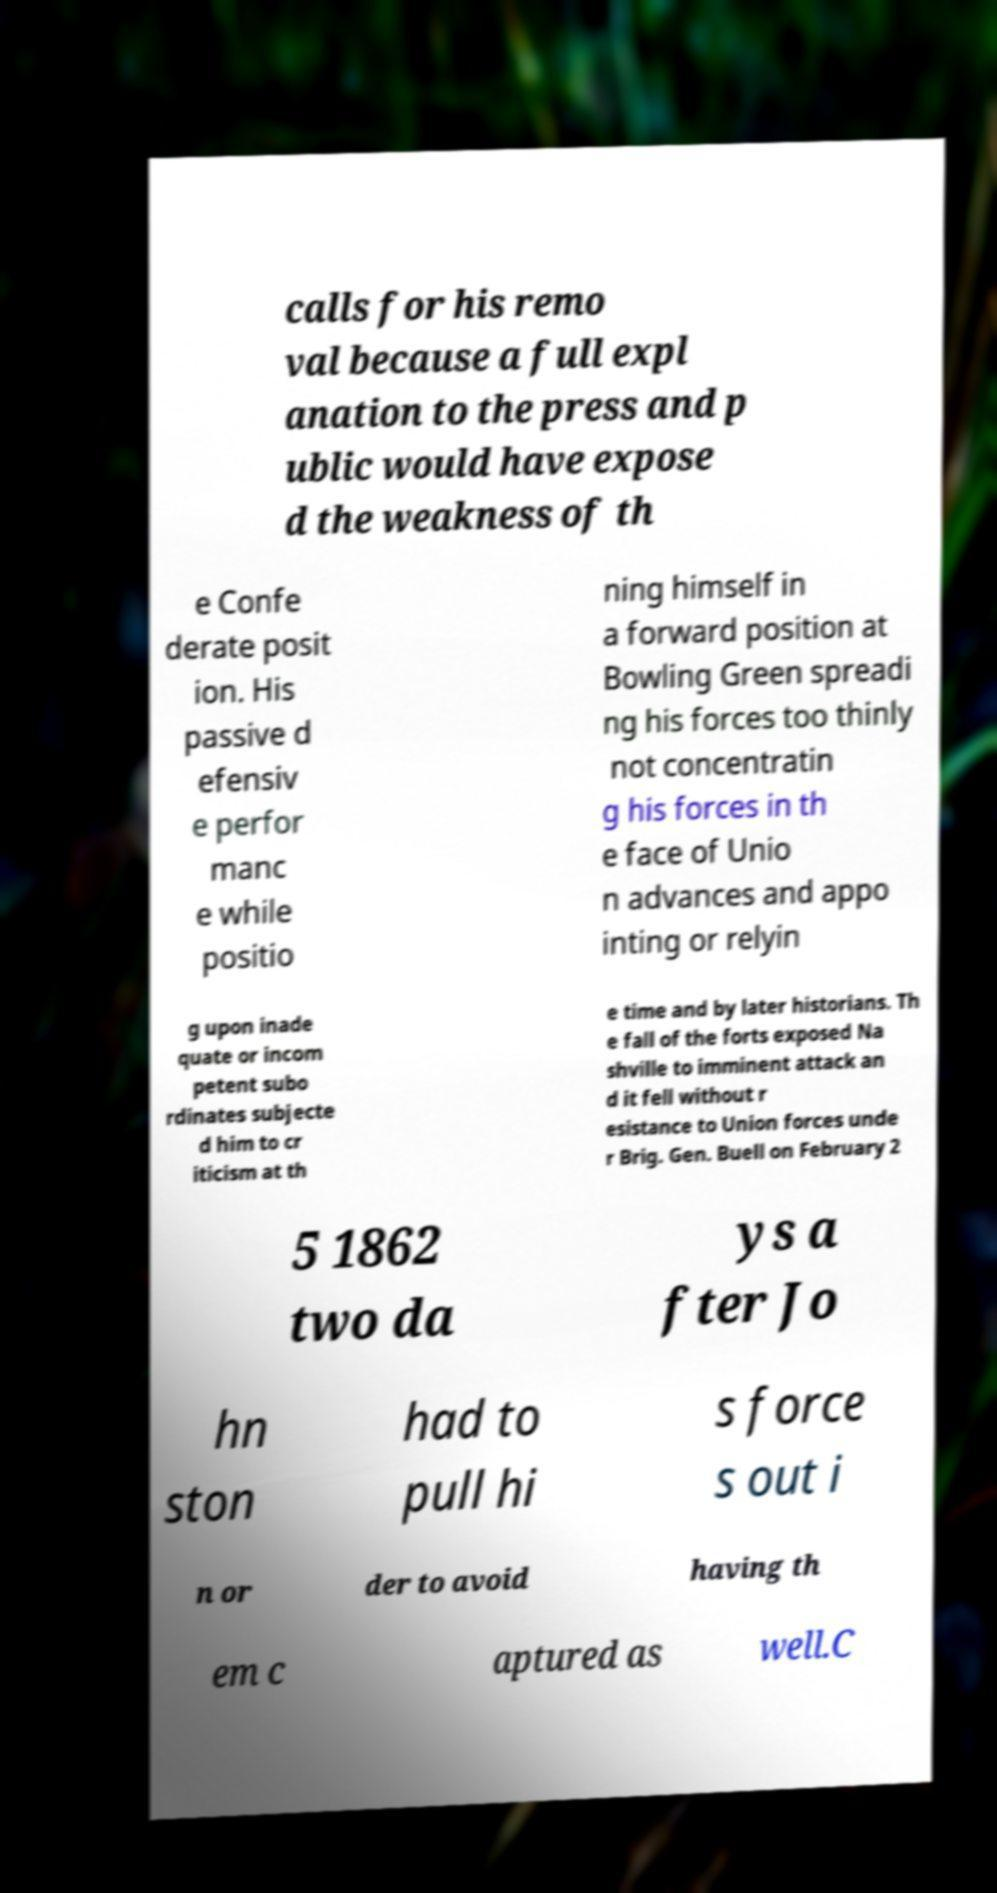Please read and relay the text visible in this image. What does it say? calls for his remo val because a full expl anation to the press and p ublic would have expose d the weakness of th e Confe derate posit ion. His passive d efensiv e perfor manc e while positio ning himself in a forward position at Bowling Green spreadi ng his forces too thinly not concentratin g his forces in th e face of Unio n advances and appo inting or relyin g upon inade quate or incom petent subo rdinates subjecte d him to cr iticism at th e time and by later historians. Th e fall of the forts exposed Na shville to imminent attack an d it fell without r esistance to Union forces unde r Brig. Gen. Buell on February 2 5 1862 two da ys a fter Jo hn ston had to pull hi s force s out i n or der to avoid having th em c aptured as well.C 